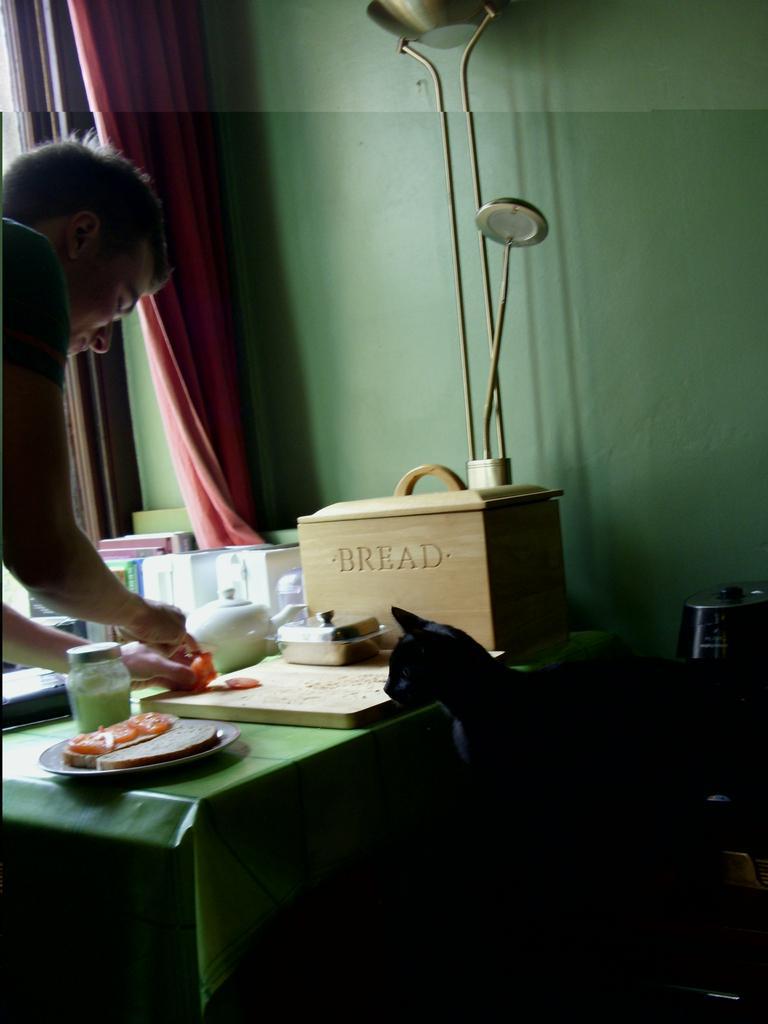In one or two sentences, can you explain what this image depicts? In this image there is a man towards the right of the image, he is holding an object, there is a table, there is a cloth on the table, there are objects on the cloth, there is a cat, there are objects towards the right of the image, there are objects towards the top of the image, there is a curtain towards the top of the image. 